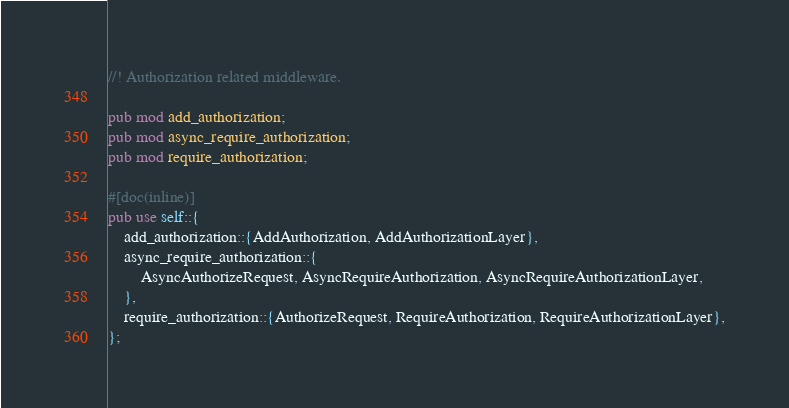Convert code to text. <code><loc_0><loc_0><loc_500><loc_500><_Rust_>//! Authorization related middleware.

pub mod add_authorization;
pub mod async_require_authorization;
pub mod require_authorization;

#[doc(inline)]
pub use self::{
    add_authorization::{AddAuthorization, AddAuthorizationLayer},
    async_require_authorization::{
        AsyncAuthorizeRequest, AsyncRequireAuthorization, AsyncRequireAuthorizationLayer,
    },
    require_authorization::{AuthorizeRequest, RequireAuthorization, RequireAuthorizationLayer},
};
</code> 